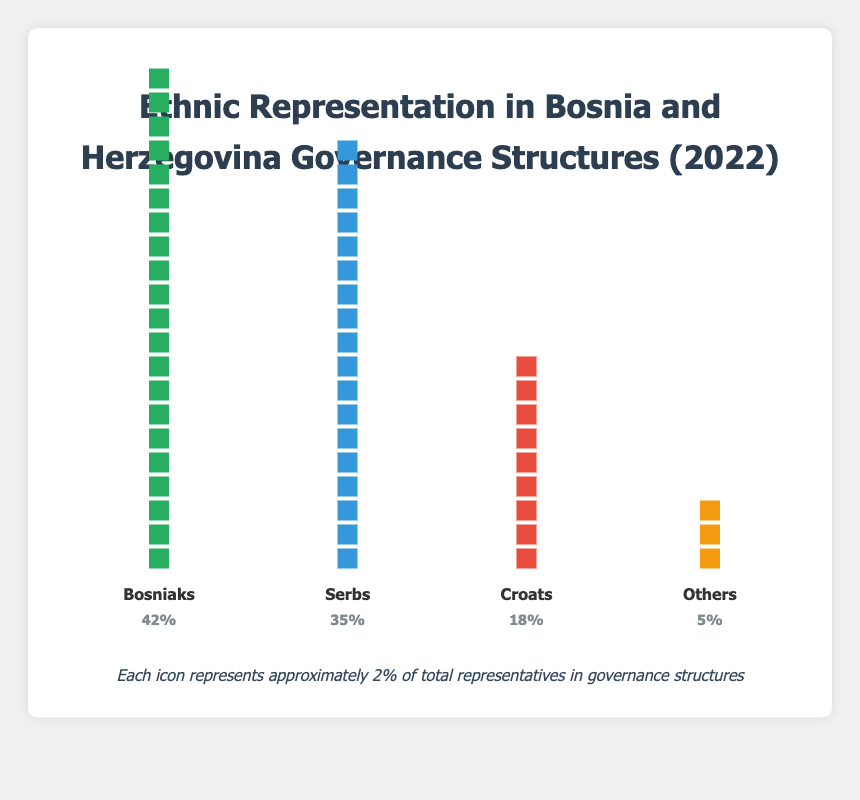What is the title of the figure? The title of the figure is at the top and it reads "Ethnic Representation in Bosnia and Herzegovina Governance Structures (2022)"
Answer: Ethnic Representation in Bosnia and Herzegovina Governance Structures (2022) Which ethnic group has the largest representation? The ethnic group with the largest representation is displayed with the most number of icons.
Answer: Bosniaks Add the percentages of representation for Serbs and Croats. What is the result? The figure shows that Serbs have 35% and Croats have 18% representation. Adding these gives 35 + 18 = 53%.
Answer: 53% Which ethnic group has the least representation? The ethnic group with the least representation can be identified by counting the number of icons and checking the percentages.
Answer: Others Compare the representation of Bosniaks with Serbs. Who has a higher percentage and by how much? Bosniaks have 42% and Serbs have 35%. Subtract the Serbs' percentage from Bosniaks' to find the difference, which is 42 - 35 = 7%.
Answer: Bosniaks by 7% What is the total sum of the percentage representations of all ethnic groups? Add the percentages of Bosniaks (42%), Serbs (35%), Croats (18%), and Others (5%). The total is 42 + 35 + 18 + 5 = 100%.
Answer: 100% How many icons represent the total percentage of all groups? As each icon represents approximately 2%, divide the total percentage (100%) by 2. This gives 100 / 2 = 50 icons.
Answer: 50 icons What percentage of the total representatives does the "Others" group constitute? Reference the percentage shown below the "Others" icon category in the figure.
Answer: 5% If the representation of Serbs increased by 3%, how many icons would represent them then? Serbs originally have 35%, which translates to 35/2 = 17.5 icons (rounded to 18 icons). If increased by 3%, they would have 38%, which translates to 38/2 = 19 icons.
Answer: 19 icons Are there any governance structures where one ethnicity has absolute dominance? Based on the percentages shown, check if any ethnic group has a percentage close to or exceeding 50%.
Answer: No 